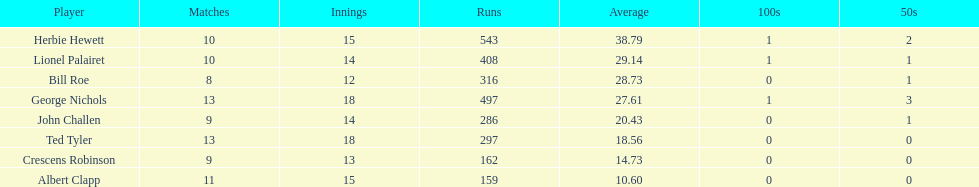Who is a player that has played in up to 13 innings? Bill Roe. 